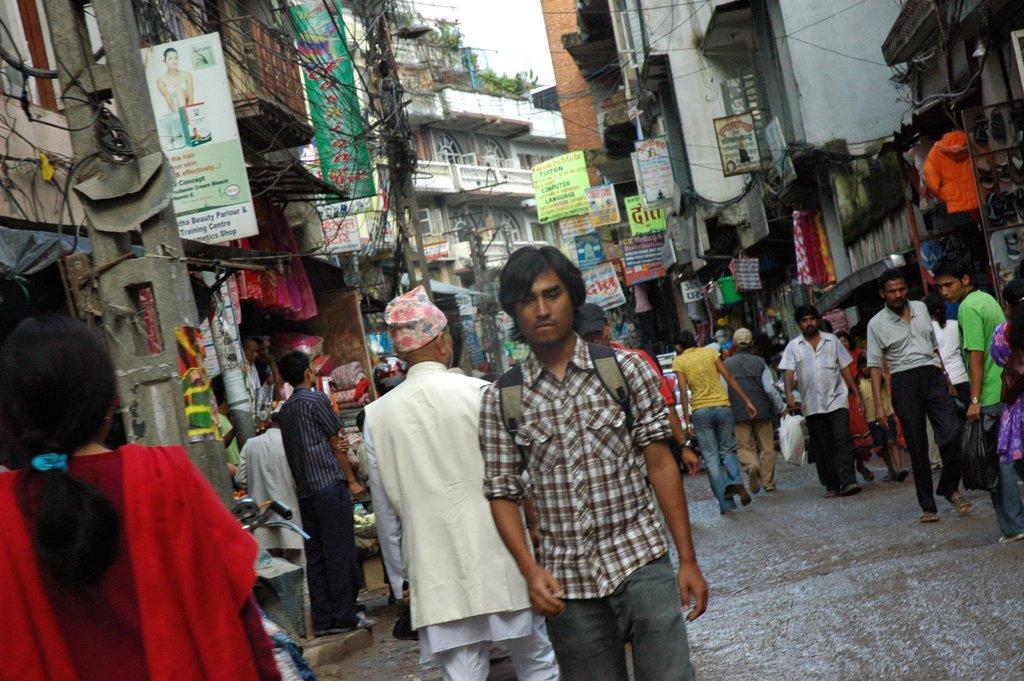Could you give a brief overview of what you see in this image? At the bottom of the image few people are walking and standing. Behind them there are some poles and banners and buildings and plants. 